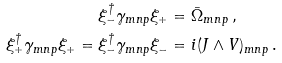<formula> <loc_0><loc_0><loc_500><loc_500>\xi ^ { \dagger } _ { - } \gamma _ { m n p } \xi _ { + } = & \ \bar { \Omega } _ { m n p } \, , \\ \xi ^ { \dagger } _ { + } \gamma _ { m n p } \xi _ { + } = \xi ^ { \dagger } _ { - } \gamma _ { m n p } \xi _ { - } = & \ i ( J \wedge V ) _ { m n p } \, .</formula> 